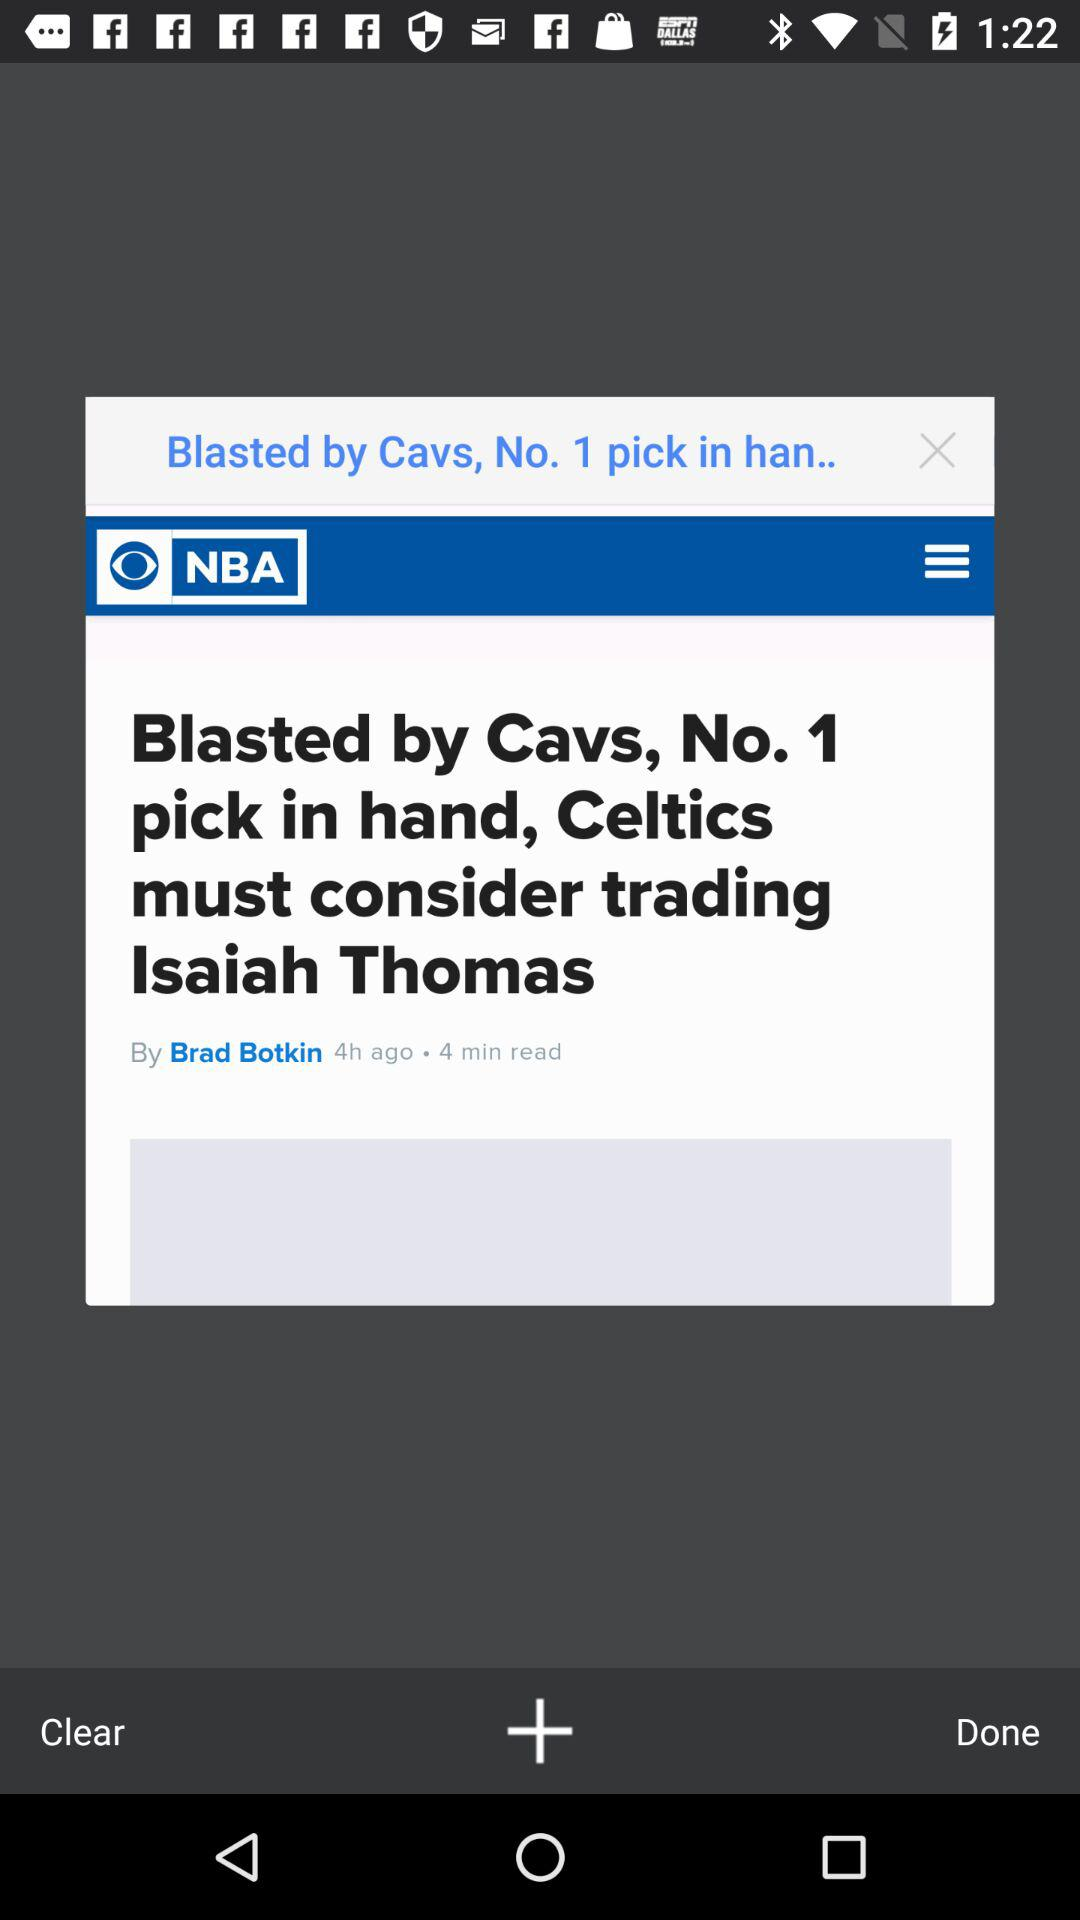What is the title of the article? The title of the article is "Blasted by Cavs, No. 1 pick in hand, Celtics must consider trading Isaiah Thomas". 